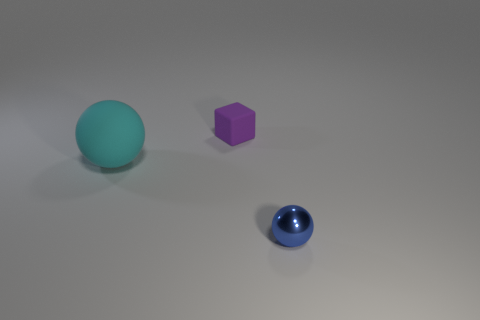What number of large things are on the left side of the matte thing that is to the right of the big matte sphere?
Offer a terse response. 1. How many blocks are either tiny rubber things or cyan rubber things?
Your answer should be compact. 1. There is a object that is both to the right of the cyan sphere and in front of the small purple thing; what is its color?
Make the answer very short. Blue. There is a tiny object that is to the right of the small thing on the left side of the blue ball; what color is it?
Offer a terse response. Blue. Do the blue shiny thing and the purple matte cube have the same size?
Ensure brevity in your answer.  Yes. Is the tiny thing that is on the left side of the small shiny sphere made of the same material as the ball to the left of the small blue metallic sphere?
Offer a very short reply. Yes. There is a matte object behind the ball behind the small blue ball that is in front of the tiny purple object; what shape is it?
Provide a succinct answer. Cube. Is the number of purple rubber cubes greater than the number of things?
Give a very brief answer. No. Is there a rubber cylinder?
Provide a succinct answer. No. What number of objects are either things that are left of the blue ball or small objects that are in front of the small purple block?
Offer a terse response. 3. 